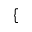Convert formula to latex. <formula><loc_0><loc_0><loc_500><loc_500>\{</formula> 